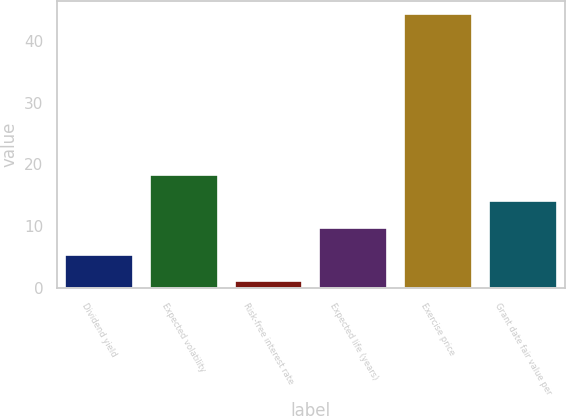Convert chart. <chart><loc_0><loc_0><loc_500><loc_500><bar_chart><fcel>Dividend yield<fcel>Expected volatility<fcel>Risk-free interest rate<fcel>Expected life (years)<fcel>Exercise price<fcel>Grant date fair value per<nl><fcel>5.38<fcel>18.34<fcel>1.06<fcel>9.7<fcel>44.29<fcel>14.02<nl></chart> 